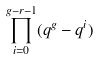Convert formula to latex. <formula><loc_0><loc_0><loc_500><loc_500>\prod _ { i = 0 } ^ { g - r - 1 } ( q ^ { g } - q ^ { i } )</formula> 